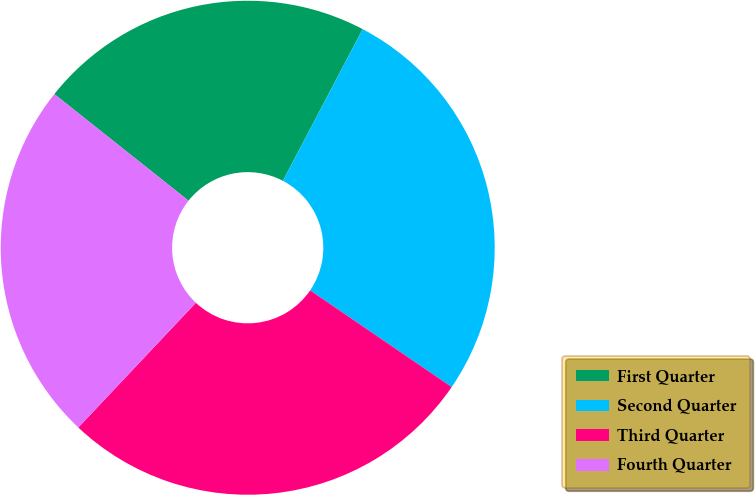<chart> <loc_0><loc_0><loc_500><loc_500><pie_chart><fcel>First Quarter<fcel>Second Quarter<fcel>Third Quarter<fcel>Fourth Quarter<nl><fcel>22.02%<fcel>26.83%<fcel>27.49%<fcel>23.66%<nl></chart> 